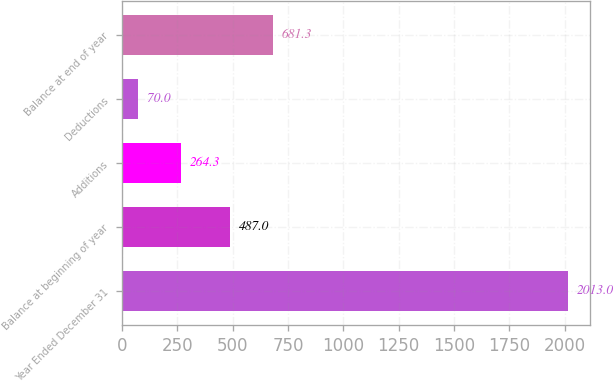<chart> <loc_0><loc_0><loc_500><loc_500><bar_chart><fcel>Year Ended December 31<fcel>Balance at beginning of year<fcel>Additions<fcel>Deductions<fcel>Balance at end of year<nl><fcel>2013<fcel>487<fcel>264.3<fcel>70<fcel>681.3<nl></chart> 